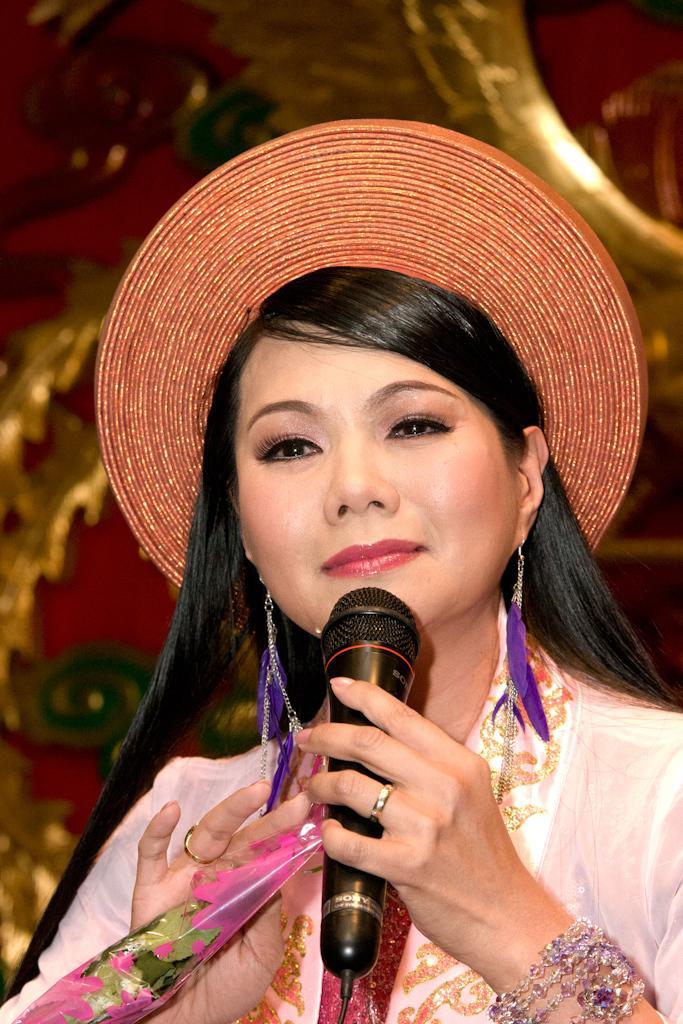Describe this image in one or two sentences. In this image there is a lady person wearing hat and holding microphone and flower in her hands. 